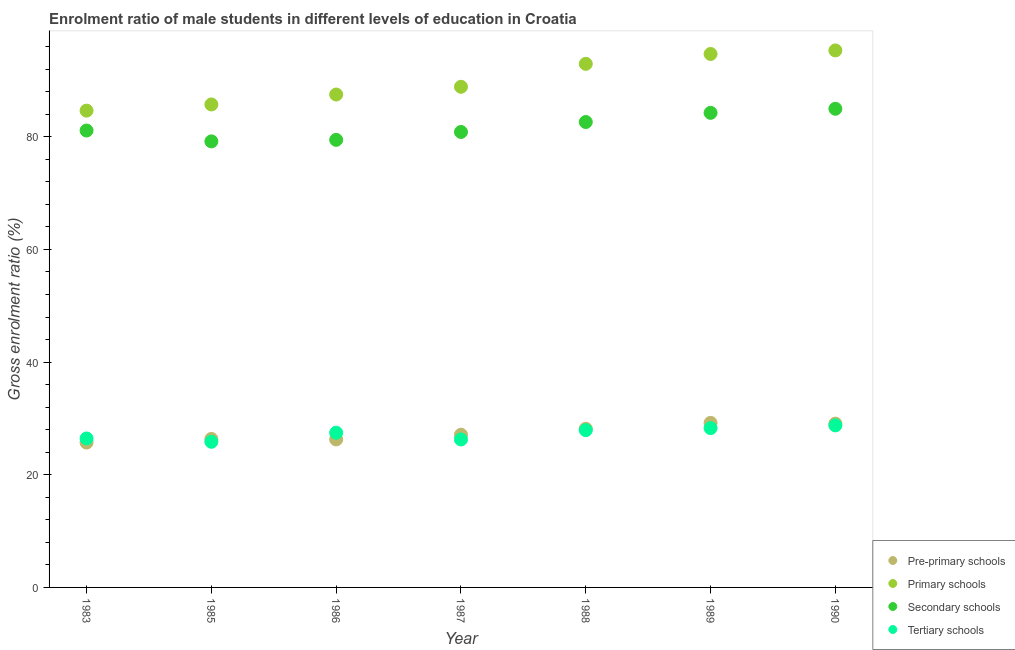How many different coloured dotlines are there?
Your response must be concise. 4. What is the gross enrolment ratio(female) in secondary schools in 1989?
Give a very brief answer. 84.25. Across all years, what is the maximum gross enrolment ratio(female) in tertiary schools?
Give a very brief answer. 28.77. Across all years, what is the minimum gross enrolment ratio(female) in primary schools?
Offer a terse response. 84.65. In which year was the gross enrolment ratio(female) in primary schools maximum?
Provide a succinct answer. 1990. What is the total gross enrolment ratio(female) in pre-primary schools in the graph?
Give a very brief answer. 191.93. What is the difference between the gross enrolment ratio(female) in tertiary schools in 1988 and that in 1990?
Offer a very short reply. -0.85. What is the difference between the gross enrolment ratio(female) in tertiary schools in 1983 and the gross enrolment ratio(female) in secondary schools in 1986?
Offer a very short reply. -53.02. What is the average gross enrolment ratio(female) in tertiary schools per year?
Ensure brevity in your answer.  27.29. In the year 1986, what is the difference between the gross enrolment ratio(female) in secondary schools and gross enrolment ratio(female) in primary schools?
Your answer should be compact. -8.05. In how many years, is the gross enrolment ratio(female) in pre-primary schools greater than 60 %?
Make the answer very short. 0. What is the ratio of the gross enrolment ratio(female) in secondary schools in 1987 to that in 1990?
Offer a very short reply. 0.95. Is the gross enrolment ratio(female) in secondary schools in 1985 less than that in 1989?
Your answer should be very brief. Yes. What is the difference between the highest and the second highest gross enrolment ratio(female) in tertiary schools?
Your answer should be very brief. 0.49. What is the difference between the highest and the lowest gross enrolment ratio(female) in pre-primary schools?
Your response must be concise. 3.49. In how many years, is the gross enrolment ratio(female) in primary schools greater than the average gross enrolment ratio(female) in primary schools taken over all years?
Your answer should be very brief. 3. Is the sum of the gross enrolment ratio(female) in secondary schools in 1983 and 1990 greater than the maximum gross enrolment ratio(female) in pre-primary schools across all years?
Offer a very short reply. Yes. Are the values on the major ticks of Y-axis written in scientific E-notation?
Offer a terse response. No. Where does the legend appear in the graph?
Your response must be concise. Bottom right. What is the title of the graph?
Make the answer very short. Enrolment ratio of male students in different levels of education in Croatia. What is the Gross enrolment ratio (%) of Pre-primary schools in 1983?
Your answer should be very brief. 25.72. What is the Gross enrolment ratio (%) of Primary schools in 1983?
Your answer should be compact. 84.65. What is the Gross enrolment ratio (%) of Secondary schools in 1983?
Make the answer very short. 81.12. What is the Gross enrolment ratio (%) in Tertiary schools in 1983?
Your answer should be very brief. 26.44. What is the Gross enrolment ratio (%) of Pre-primary schools in 1985?
Offer a very short reply. 26.36. What is the Gross enrolment ratio (%) in Primary schools in 1985?
Your answer should be very brief. 85.74. What is the Gross enrolment ratio (%) of Secondary schools in 1985?
Your response must be concise. 79.19. What is the Gross enrolment ratio (%) in Tertiary schools in 1985?
Offer a very short reply. 25.86. What is the Gross enrolment ratio (%) of Pre-primary schools in 1986?
Your response must be concise. 26.27. What is the Gross enrolment ratio (%) of Primary schools in 1986?
Provide a succinct answer. 87.51. What is the Gross enrolment ratio (%) in Secondary schools in 1986?
Offer a terse response. 79.46. What is the Gross enrolment ratio (%) in Tertiary schools in 1986?
Your answer should be very brief. 27.47. What is the Gross enrolment ratio (%) of Pre-primary schools in 1987?
Provide a short and direct response. 27.11. What is the Gross enrolment ratio (%) in Primary schools in 1987?
Your answer should be very brief. 88.88. What is the Gross enrolment ratio (%) in Secondary schools in 1987?
Your response must be concise. 80.86. What is the Gross enrolment ratio (%) in Tertiary schools in 1987?
Make the answer very short. 26.27. What is the Gross enrolment ratio (%) of Pre-primary schools in 1988?
Offer a very short reply. 28.17. What is the Gross enrolment ratio (%) of Primary schools in 1988?
Offer a terse response. 92.95. What is the Gross enrolment ratio (%) in Secondary schools in 1988?
Provide a succinct answer. 82.62. What is the Gross enrolment ratio (%) in Tertiary schools in 1988?
Give a very brief answer. 27.92. What is the Gross enrolment ratio (%) of Pre-primary schools in 1989?
Your answer should be compact. 29.21. What is the Gross enrolment ratio (%) of Primary schools in 1989?
Your answer should be compact. 94.71. What is the Gross enrolment ratio (%) in Secondary schools in 1989?
Offer a very short reply. 84.25. What is the Gross enrolment ratio (%) of Tertiary schools in 1989?
Keep it short and to the point. 28.28. What is the Gross enrolment ratio (%) of Pre-primary schools in 1990?
Your answer should be very brief. 29.08. What is the Gross enrolment ratio (%) of Primary schools in 1990?
Offer a terse response. 95.34. What is the Gross enrolment ratio (%) in Secondary schools in 1990?
Offer a very short reply. 84.98. What is the Gross enrolment ratio (%) in Tertiary schools in 1990?
Offer a very short reply. 28.77. Across all years, what is the maximum Gross enrolment ratio (%) of Pre-primary schools?
Keep it short and to the point. 29.21. Across all years, what is the maximum Gross enrolment ratio (%) in Primary schools?
Provide a succinct answer. 95.34. Across all years, what is the maximum Gross enrolment ratio (%) in Secondary schools?
Your response must be concise. 84.98. Across all years, what is the maximum Gross enrolment ratio (%) of Tertiary schools?
Your response must be concise. 28.77. Across all years, what is the minimum Gross enrolment ratio (%) in Pre-primary schools?
Your response must be concise. 25.72. Across all years, what is the minimum Gross enrolment ratio (%) in Primary schools?
Your answer should be very brief. 84.65. Across all years, what is the minimum Gross enrolment ratio (%) of Secondary schools?
Provide a succinct answer. 79.19. Across all years, what is the minimum Gross enrolment ratio (%) in Tertiary schools?
Your response must be concise. 25.86. What is the total Gross enrolment ratio (%) in Pre-primary schools in the graph?
Provide a short and direct response. 191.93. What is the total Gross enrolment ratio (%) of Primary schools in the graph?
Provide a succinct answer. 629.77. What is the total Gross enrolment ratio (%) of Secondary schools in the graph?
Offer a terse response. 572.48. What is the total Gross enrolment ratio (%) of Tertiary schools in the graph?
Provide a succinct answer. 191.01. What is the difference between the Gross enrolment ratio (%) of Pre-primary schools in 1983 and that in 1985?
Provide a succinct answer. -0.65. What is the difference between the Gross enrolment ratio (%) of Primary schools in 1983 and that in 1985?
Your response must be concise. -1.1. What is the difference between the Gross enrolment ratio (%) of Secondary schools in 1983 and that in 1985?
Ensure brevity in your answer.  1.92. What is the difference between the Gross enrolment ratio (%) of Tertiary schools in 1983 and that in 1985?
Provide a succinct answer. 0.59. What is the difference between the Gross enrolment ratio (%) in Pre-primary schools in 1983 and that in 1986?
Offer a very short reply. -0.56. What is the difference between the Gross enrolment ratio (%) of Primary schools in 1983 and that in 1986?
Offer a very short reply. -2.86. What is the difference between the Gross enrolment ratio (%) in Secondary schools in 1983 and that in 1986?
Make the answer very short. 1.66. What is the difference between the Gross enrolment ratio (%) of Tertiary schools in 1983 and that in 1986?
Offer a very short reply. -1.02. What is the difference between the Gross enrolment ratio (%) of Pre-primary schools in 1983 and that in 1987?
Ensure brevity in your answer.  -1.39. What is the difference between the Gross enrolment ratio (%) in Primary schools in 1983 and that in 1987?
Offer a terse response. -4.23. What is the difference between the Gross enrolment ratio (%) in Secondary schools in 1983 and that in 1987?
Your answer should be very brief. 0.26. What is the difference between the Gross enrolment ratio (%) in Tertiary schools in 1983 and that in 1987?
Provide a short and direct response. 0.18. What is the difference between the Gross enrolment ratio (%) of Pre-primary schools in 1983 and that in 1988?
Your answer should be compact. -2.45. What is the difference between the Gross enrolment ratio (%) of Primary schools in 1983 and that in 1988?
Your answer should be very brief. -8.31. What is the difference between the Gross enrolment ratio (%) of Secondary schools in 1983 and that in 1988?
Make the answer very short. -1.51. What is the difference between the Gross enrolment ratio (%) of Tertiary schools in 1983 and that in 1988?
Offer a terse response. -1.48. What is the difference between the Gross enrolment ratio (%) of Pre-primary schools in 1983 and that in 1989?
Offer a terse response. -3.49. What is the difference between the Gross enrolment ratio (%) of Primary schools in 1983 and that in 1989?
Keep it short and to the point. -10.06. What is the difference between the Gross enrolment ratio (%) in Secondary schools in 1983 and that in 1989?
Make the answer very short. -3.14. What is the difference between the Gross enrolment ratio (%) in Tertiary schools in 1983 and that in 1989?
Keep it short and to the point. -1.84. What is the difference between the Gross enrolment ratio (%) of Pre-primary schools in 1983 and that in 1990?
Keep it short and to the point. -3.36. What is the difference between the Gross enrolment ratio (%) of Primary schools in 1983 and that in 1990?
Make the answer very short. -10.69. What is the difference between the Gross enrolment ratio (%) in Secondary schools in 1983 and that in 1990?
Provide a succinct answer. -3.86. What is the difference between the Gross enrolment ratio (%) in Tertiary schools in 1983 and that in 1990?
Give a very brief answer. -2.32. What is the difference between the Gross enrolment ratio (%) of Pre-primary schools in 1985 and that in 1986?
Keep it short and to the point. 0.09. What is the difference between the Gross enrolment ratio (%) in Primary schools in 1985 and that in 1986?
Your answer should be compact. -1.77. What is the difference between the Gross enrolment ratio (%) in Secondary schools in 1985 and that in 1986?
Make the answer very short. -0.27. What is the difference between the Gross enrolment ratio (%) of Tertiary schools in 1985 and that in 1986?
Give a very brief answer. -1.61. What is the difference between the Gross enrolment ratio (%) of Pre-primary schools in 1985 and that in 1987?
Make the answer very short. -0.75. What is the difference between the Gross enrolment ratio (%) of Primary schools in 1985 and that in 1987?
Offer a very short reply. -3.14. What is the difference between the Gross enrolment ratio (%) in Secondary schools in 1985 and that in 1987?
Ensure brevity in your answer.  -1.67. What is the difference between the Gross enrolment ratio (%) in Tertiary schools in 1985 and that in 1987?
Give a very brief answer. -0.41. What is the difference between the Gross enrolment ratio (%) in Pre-primary schools in 1985 and that in 1988?
Offer a very short reply. -1.81. What is the difference between the Gross enrolment ratio (%) in Primary schools in 1985 and that in 1988?
Provide a short and direct response. -7.21. What is the difference between the Gross enrolment ratio (%) in Secondary schools in 1985 and that in 1988?
Make the answer very short. -3.43. What is the difference between the Gross enrolment ratio (%) of Tertiary schools in 1985 and that in 1988?
Keep it short and to the point. -2.07. What is the difference between the Gross enrolment ratio (%) in Pre-primary schools in 1985 and that in 1989?
Make the answer very short. -2.85. What is the difference between the Gross enrolment ratio (%) of Primary schools in 1985 and that in 1989?
Give a very brief answer. -8.96. What is the difference between the Gross enrolment ratio (%) of Secondary schools in 1985 and that in 1989?
Provide a short and direct response. -5.06. What is the difference between the Gross enrolment ratio (%) in Tertiary schools in 1985 and that in 1989?
Your answer should be very brief. -2.42. What is the difference between the Gross enrolment ratio (%) in Pre-primary schools in 1985 and that in 1990?
Keep it short and to the point. -2.71. What is the difference between the Gross enrolment ratio (%) of Primary schools in 1985 and that in 1990?
Provide a short and direct response. -9.59. What is the difference between the Gross enrolment ratio (%) in Secondary schools in 1985 and that in 1990?
Your answer should be compact. -5.79. What is the difference between the Gross enrolment ratio (%) in Tertiary schools in 1985 and that in 1990?
Offer a very short reply. -2.91. What is the difference between the Gross enrolment ratio (%) in Pre-primary schools in 1986 and that in 1987?
Provide a short and direct response. -0.84. What is the difference between the Gross enrolment ratio (%) in Primary schools in 1986 and that in 1987?
Your response must be concise. -1.37. What is the difference between the Gross enrolment ratio (%) in Secondary schools in 1986 and that in 1987?
Offer a terse response. -1.4. What is the difference between the Gross enrolment ratio (%) in Tertiary schools in 1986 and that in 1987?
Offer a very short reply. 1.2. What is the difference between the Gross enrolment ratio (%) in Pre-primary schools in 1986 and that in 1988?
Your answer should be very brief. -1.9. What is the difference between the Gross enrolment ratio (%) in Primary schools in 1986 and that in 1988?
Offer a very short reply. -5.44. What is the difference between the Gross enrolment ratio (%) of Secondary schools in 1986 and that in 1988?
Offer a terse response. -3.17. What is the difference between the Gross enrolment ratio (%) in Tertiary schools in 1986 and that in 1988?
Ensure brevity in your answer.  -0.46. What is the difference between the Gross enrolment ratio (%) of Pre-primary schools in 1986 and that in 1989?
Your answer should be compact. -2.94. What is the difference between the Gross enrolment ratio (%) of Primary schools in 1986 and that in 1989?
Your response must be concise. -7.2. What is the difference between the Gross enrolment ratio (%) in Secondary schools in 1986 and that in 1989?
Your answer should be compact. -4.79. What is the difference between the Gross enrolment ratio (%) of Tertiary schools in 1986 and that in 1989?
Provide a short and direct response. -0.81. What is the difference between the Gross enrolment ratio (%) of Pre-primary schools in 1986 and that in 1990?
Make the answer very short. -2.8. What is the difference between the Gross enrolment ratio (%) of Primary schools in 1986 and that in 1990?
Make the answer very short. -7.83. What is the difference between the Gross enrolment ratio (%) in Secondary schools in 1986 and that in 1990?
Offer a very short reply. -5.52. What is the difference between the Gross enrolment ratio (%) in Tertiary schools in 1986 and that in 1990?
Keep it short and to the point. -1.3. What is the difference between the Gross enrolment ratio (%) of Pre-primary schools in 1987 and that in 1988?
Give a very brief answer. -1.06. What is the difference between the Gross enrolment ratio (%) of Primary schools in 1987 and that in 1988?
Offer a very short reply. -4.07. What is the difference between the Gross enrolment ratio (%) in Secondary schools in 1987 and that in 1988?
Offer a very short reply. -1.77. What is the difference between the Gross enrolment ratio (%) of Tertiary schools in 1987 and that in 1988?
Make the answer very short. -1.65. What is the difference between the Gross enrolment ratio (%) of Pre-primary schools in 1987 and that in 1989?
Provide a short and direct response. -2.1. What is the difference between the Gross enrolment ratio (%) in Primary schools in 1987 and that in 1989?
Provide a short and direct response. -5.83. What is the difference between the Gross enrolment ratio (%) of Secondary schools in 1987 and that in 1989?
Your answer should be very brief. -3.39. What is the difference between the Gross enrolment ratio (%) in Tertiary schools in 1987 and that in 1989?
Provide a succinct answer. -2.01. What is the difference between the Gross enrolment ratio (%) in Pre-primary schools in 1987 and that in 1990?
Make the answer very short. -1.97. What is the difference between the Gross enrolment ratio (%) in Primary schools in 1987 and that in 1990?
Offer a very short reply. -6.45. What is the difference between the Gross enrolment ratio (%) of Secondary schools in 1987 and that in 1990?
Offer a terse response. -4.12. What is the difference between the Gross enrolment ratio (%) of Tertiary schools in 1987 and that in 1990?
Offer a very short reply. -2.5. What is the difference between the Gross enrolment ratio (%) in Pre-primary schools in 1988 and that in 1989?
Make the answer very short. -1.04. What is the difference between the Gross enrolment ratio (%) in Primary schools in 1988 and that in 1989?
Ensure brevity in your answer.  -1.75. What is the difference between the Gross enrolment ratio (%) of Secondary schools in 1988 and that in 1989?
Your answer should be very brief. -1.63. What is the difference between the Gross enrolment ratio (%) in Tertiary schools in 1988 and that in 1989?
Keep it short and to the point. -0.36. What is the difference between the Gross enrolment ratio (%) in Pre-primary schools in 1988 and that in 1990?
Offer a terse response. -0.91. What is the difference between the Gross enrolment ratio (%) in Primary schools in 1988 and that in 1990?
Provide a succinct answer. -2.38. What is the difference between the Gross enrolment ratio (%) of Secondary schools in 1988 and that in 1990?
Your answer should be compact. -2.35. What is the difference between the Gross enrolment ratio (%) of Tertiary schools in 1988 and that in 1990?
Ensure brevity in your answer.  -0.85. What is the difference between the Gross enrolment ratio (%) in Pre-primary schools in 1989 and that in 1990?
Give a very brief answer. 0.14. What is the difference between the Gross enrolment ratio (%) of Primary schools in 1989 and that in 1990?
Provide a short and direct response. -0.63. What is the difference between the Gross enrolment ratio (%) of Secondary schools in 1989 and that in 1990?
Offer a terse response. -0.73. What is the difference between the Gross enrolment ratio (%) in Tertiary schools in 1989 and that in 1990?
Keep it short and to the point. -0.49. What is the difference between the Gross enrolment ratio (%) of Pre-primary schools in 1983 and the Gross enrolment ratio (%) of Primary schools in 1985?
Keep it short and to the point. -60.02. What is the difference between the Gross enrolment ratio (%) in Pre-primary schools in 1983 and the Gross enrolment ratio (%) in Secondary schools in 1985?
Offer a terse response. -53.47. What is the difference between the Gross enrolment ratio (%) in Pre-primary schools in 1983 and the Gross enrolment ratio (%) in Tertiary schools in 1985?
Offer a terse response. -0.14. What is the difference between the Gross enrolment ratio (%) of Primary schools in 1983 and the Gross enrolment ratio (%) of Secondary schools in 1985?
Give a very brief answer. 5.45. What is the difference between the Gross enrolment ratio (%) in Primary schools in 1983 and the Gross enrolment ratio (%) in Tertiary schools in 1985?
Offer a very short reply. 58.79. What is the difference between the Gross enrolment ratio (%) in Secondary schools in 1983 and the Gross enrolment ratio (%) in Tertiary schools in 1985?
Offer a very short reply. 55.26. What is the difference between the Gross enrolment ratio (%) in Pre-primary schools in 1983 and the Gross enrolment ratio (%) in Primary schools in 1986?
Offer a terse response. -61.79. What is the difference between the Gross enrolment ratio (%) in Pre-primary schools in 1983 and the Gross enrolment ratio (%) in Secondary schools in 1986?
Keep it short and to the point. -53.74. What is the difference between the Gross enrolment ratio (%) in Pre-primary schools in 1983 and the Gross enrolment ratio (%) in Tertiary schools in 1986?
Keep it short and to the point. -1.75. What is the difference between the Gross enrolment ratio (%) in Primary schools in 1983 and the Gross enrolment ratio (%) in Secondary schools in 1986?
Your answer should be very brief. 5.19. What is the difference between the Gross enrolment ratio (%) in Primary schools in 1983 and the Gross enrolment ratio (%) in Tertiary schools in 1986?
Ensure brevity in your answer.  57.18. What is the difference between the Gross enrolment ratio (%) of Secondary schools in 1983 and the Gross enrolment ratio (%) of Tertiary schools in 1986?
Keep it short and to the point. 53.65. What is the difference between the Gross enrolment ratio (%) in Pre-primary schools in 1983 and the Gross enrolment ratio (%) in Primary schools in 1987?
Your answer should be very brief. -63.16. What is the difference between the Gross enrolment ratio (%) of Pre-primary schools in 1983 and the Gross enrolment ratio (%) of Secondary schools in 1987?
Make the answer very short. -55.14. What is the difference between the Gross enrolment ratio (%) of Pre-primary schools in 1983 and the Gross enrolment ratio (%) of Tertiary schools in 1987?
Offer a terse response. -0.55. What is the difference between the Gross enrolment ratio (%) of Primary schools in 1983 and the Gross enrolment ratio (%) of Secondary schools in 1987?
Your answer should be compact. 3.79. What is the difference between the Gross enrolment ratio (%) of Primary schools in 1983 and the Gross enrolment ratio (%) of Tertiary schools in 1987?
Keep it short and to the point. 58.38. What is the difference between the Gross enrolment ratio (%) of Secondary schools in 1983 and the Gross enrolment ratio (%) of Tertiary schools in 1987?
Your answer should be very brief. 54.85. What is the difference between the Gross enrolment ratio (%) of Pre-primary schools in 1983 and the Gross enrolment ratio (%) of Primary schools in 1988?
Provide a short and direct response. -67.24. What is the difference between the Gross enrolment ratio (%) in Pre-primary schools in 1983 and the Gross enrolment ratio (%) in Secondary schools in 1988?
Keep it short and to the point. -56.91. What is the difference between the Gross enrolment ratio (%) of Pre-primary schools in 1983 and the Gross enrolment ratio (%) of Tertiary schools in 1988?
Make the answer very short. -2.2. What is the difference between the Gross enrolment ratio (%) in Primary schools in 1983 and the Gross enrolment ratio (%) in Secondary schools in 1988?
Provide a succinct answer. 2.02. What is the difference between the Gross enrolment ratio (%) of Primary schools in 1983 and the Gross enrolment ratio (%) of Tertiary schools in 1988?
Your answer should be compact. 56.72. What is the difference between the Gross enrolment ratio (%) of Secondary schools in 1983 and the Gross enrolment ratio (%) of Tertiary schools in 1988?
Provide a succinct answer. 53.19. What is the difference between the Gross enrolment ratio (%) in Pre-primary schools in 1983 and the Gross enrolment ratio (%) in Primary schools in 1989?
Provide a short and direct response. -68.99. What is the difference between the Gross enrolment ratio (%) of Pre-primary schools in 1983 and the Gross enrolment ratio (%) of Secondary schools in 1989?
Your answer should be very brief. -58.53. What is the difference between the Gross enrolment ratio (%) in Pre-primary schools in 1983 and the Gross enrolment ratio (%) in Tertiary schools in 1989?
Provide a succinct answer. -2.56. What is the difference between the Gross enrolment ratio (%) in Primary schools in 1983 and the Gross enrolment ratio (%) in Secondary schools in 1989?
Offer a very short reply. 0.39. What is the difference between the Gross enrolment ratio (%) of Primary schools in 1983 and the Gross enrolment ratio (%) of Tertiary schools in 1989?
Keep it short and to the point. 56.37. What is the difference between the Gross enrolment ratio (%) in Secondary schools in 1983 and the Gross enrolment ratio (%) in Tertiary schools in 1989?
Offer a very short reply. 52.84. What is the difference between the Gross enrolment ratio (%) in Pre-primary schools in 1983 and the Gross enrolment ratio (%) in Primary schools in 1990?
Offer a terse response. -69.62. What is the difference between the Gross enrolment ratio (%) of Pre-primary schools in 1983 and the Gross enrolment ratio (%) of Secondary schools in 1990?
Your response must be concise. -59.26. What is the difference between the Gross enrolment ratio (%) of Pre-primary schools in 1983 and the Gross enrolment ratio (%) of Tertiary schools in 1990?
Your answer should be compact. -3.05. What is the difference between the Gross enrolment ratio (%) in Primary schools in 1983 and the Gross enrolment ratio (%) in Secondary schools in 1990?
Offer a very short reply. -0.33. What is the difference between the Gross enrolment ratio (%) of Primary schools in 1983 and the Gross enrolment ratio (%) of Tertiary schools in 1990?
Provide a succinct answer. 55.88. What is the difference between the Gross enrolment ratio (%) of Secondary schools in 1983 and the Gross enrolment ratio (%) of Tertiary schools in 1990?
Make the answer very short. 52.35. What is the difference between the Gross enrolment ratio (%) in Pre-primary schools in 1985 and the Gross enrolment ratio (%) in Primary schools in 1986?
Provide a short and direct response. -61.15. What is the difference between the Gross enrolment ratio (%) of Pre-primary schools in 1985 and the Gross enrolment ratio (%) of Secondary schools in 1986?
Give a very brief answer. -53.1. What is the difference between the Gross enrolment ratio (%) in Pre-primary schools in 1985 and the Gross enrolment ratio (%) in Tertiary schools in 1986?
Provide a succinct answer. -1.1. What is the difference between the Gross enrolment ratio (%) in Primary schools in 1985 and the Gross enrolment ratio (%) in Secondary schools in 1986?
Ensure brevity in your answer.  6.28. What is the difference between the Gross enrolment ratio (%) in Primary schools in 1985 and the Gross enrolment ratio (%) in Tertiary schools in 1986?
Offer a very short reply. 58.27. What is the difference between the Gross enrolment ratio (%) of Secondary schools in 1985 and the Gross enrolment ratio (%) of Tertiary schools in 1986?
Your response must be concise. 51.72. What is the difference between the Gross enrolment ratio (%) in Pre-primary schools in 1985 and the Gross enrolment ratio (%) in Primary schools in 1987?
Provide a short and direct response. -62.52. What is the difference between the Gross enrolment ratio (%) of Pre-primary schools in 1985 and the Gross enrolment ratio (%) of Secondary schools in 1987?
Give a very brief answer. -54.5. What is the difference between the Gross enrolment ratio (%) in Pre-primary schools in 1985 and the Gross enrolment ratio (%) in Tertiary schools in 1987?
Your response must be concise. 0.1. What is the difference between the Gross enrolment ratio (%) of Primary schools in 1985 and the Gross enrolment ratio (%) of Secondary schools in 1987?
Your answer should be compact. 4.88. What is the difference between the Gross enrolment ratio (%) in Primary schools in 1985 and the Gross enrolment ratio (%) in Tertiary schools in 1987?
Provide a short and direct response. 59.47. What is the difference between the Gross enrolment ratio (%) of Secondary schools in 1985 and the Gross enrolment ratio (%) of Tertiary schools in 1987?
Provide a succinct answer. 52.92. What is the difference between the Gross enrolment ratio (%) in Pre-primary schools in 1985 and the Gross enrolment ratio (%) in Primary schools in 1988?
Your answer should be very brief. -66.59. What is the difference between the Gross enrolment ratio (%) of Pre-primary schools in 1985 and the Gross enrolment ratio (%) of Secondary schools in 1988?
Ensure brevity in your answer.  -56.26. What is the difference between the Gross enrolment ratio (%) in Pre-primary schools in 1985 and the Gross enrolment ratio (%) in Tertiary schools in 1988?
Provide a succinct answer. -1.56. What is the difference between the Gross enrolment ratio (%) in Primary schools in 1985 and the Gross enrolment ratio (%) in Secondary schools in 1988?
Make the answer very short. 3.12. What is the difference between the Gross enrolment ratio (%) of Primary schools in 1985 and the Gross enrolment ratio (%) of Tertiary schools in 1988?
Give a very brief answer. 57.82. What is the difference between the Gross enrolment ratio (%) in Secondary schools in 1985 and the Gross enrolment ratio (%) in Tertiary schools in 1988?
Your response must be concise. 51.27. What is the difference between the Gross enrolment ratio (%) of Pre-primary schools in 1985 and the Gross enrolment ratio (%) of Primary schools in 1989?
Your answer should be compact. -68.34. What is the difference between the Gross enrolment ratio (%) of Pre-primary schools in 1985 and the Gross enrolment ratio (%) of Secondary schools in 1989?
Make the answer very short. -57.89. What is the difference between the Gross enrolment ratio (%) of Pre-primary schools in 1985 and the Gross enrolment ratio (%) of Tertiary schools in 1989?
Offer a very short reply. -1.92. What is the difference between the Gross enrolment ratio (%) in Primary schools in 1985 and the Gross enrolment ratio (%) in Secondary schools in 1989?
Your response must be concise. 1.49. What is the difference between the Gross enrolment ratio (%) in Primary schools in 1985 and the Gross enrolment ratio (%) in Tertiary schools in 1989?
Make the answer very short. 57.46. What is the difference between the Gross enrolment ratio (%) in Secondary schools in 1985 and the Gross enrolment ratio (%) in Tertiary schools in 1989?
Keep it short and to the point. 50.91. What is the difference between the Gross enrolment ratio (%) in Pre-primary schools in 1985 and the Gross enrolment ratio (%) in Primary schools in 1990?
Offer a terse response. -68.97. What is the difference between the Gross enrolment ratio (%) of Pre-primary schools in 1985 and the Gross enrolment ratio (%) of Secondary schools in 1990?
Offer a very short reply. -58.61. What is the difference between the Gross enrolment ratio (%) of Pre-primary schools in 1985 and the Gross enrolment ratio (%) of Tertiary schools in 1990?
Provide a succinct answer. -2.4. What is the difference between the Gross enrolment ratio (%) in Primary schools in 1985 and the Gross enrolment ratio (%) in Secondary schools in 1990?
Make the answer very short. 0.76. What is the difference between the Gross enrolment ratio (%) in Primary schools in 1985 and the Gross enrolment ratio (%) in Tertiary schools in 1990?
Provide a succinct answer. 56.97. What is the difference between the Gross enrolment ratio (%) of Secondary schools in 1985 and the Gross enrolment ratio (%) of Tertiary schools in 1990?
Offer a terse response. 50.42. What is the difference between the Gross enrolment ratio (%) in Pre-primary schools in 1986 and the Gross enrolment ratio (%) in Primary schools in 1987?
Offer a terse response. -62.61. What is the difference between the Gross enrolment ratio (%) in Pre-primary schools in 1986 and the Gross enrolment ratio (%) in Secondary schools in 1987?
Offer a terse response. -54.59. What is the difference between the Gross enrolment ratio (%) of Pre-primary schools in 1986 and the Gross enrolment ratio (%) of Tertiary schools in 1987?
Your answer should be very brief. 0.01. What is the difference between the Gross enrolment ratio (%) of Primary schools in 1986 and the Gross enrolment ratio (%) of Secondary schools in 1987?
Provide a succinct answer. 6.65. What is the difference between the Gross enrolment ratio (%) of Primary schools in 1986 and the Gross enrolment ratio (%) of Tertiary schools in 1987?
Offer a terse response. 61.24. What is the difference between the Gross enrolment ratio (%) of Secondary schools in 1986 and the Gross enrolment ratio (%) of Tertiary schools in 1987?
Give a very brief answer. 53.19. What is the difference between the Gross enrolment ratio (%) of Pre-primary schools in 1986 and the Gross enrolment ratio (%) of Primary schools in 1988?
Provide a succinct answer. -66.68. What is the difference between the Gross enrolment ratio (%) in Pre-primary schools in 1986 and the Gross enrolment ratio (%) in Secondary schools in 1988?
Provide a short and direct response. -56.35. What is the difference between the Gross enrolment ratio (%) in Pre-primary schools in 1986 and the Gross enrolment ratio (%) in Tertiary schools in 1988?
Your answer should be very brief. -1.65. What is the difference between the Gross enrolment ratio (%) of Primary schools in 1986 and the Gross enrolment ratio (%) of Secondary schools in 1988?
Provide a succinct answer. 4.88. What is the difference between the Gross enrolment ratio (%) in Primary schools in 1986 and the Gross enrolment ratio (%) in Tertiary schools in 1988?
Provide a short and direct response. 59.59. What is the difference between the Gross enrolment ratio (%) of Secondary schools in 1986 and the Gross enrolment ratio (%) of Tertiary schools in 1988?
Your answer should be very brief. 51.54. What is the difference between the Gross enrolment ratio (%) of Pre-primary schools in 1986 and the Gross enrolment ratio (%) of Primary schools in 1989?
Provide a succinct answer. -68.43. What is the difference between the Gross enrolment ratio (%) in Pre-primary schools in 1986 and the Gross enrolment ratio (%) in Secondary schools in 1989?
Give a very brief answer. -57.98. What is the difference between the Gross enrolment ratio (%) of Pre-primary schools in 1986 and the Gross enrolment ratio (%) of Tertiary schools in 1989?
Offer a very short reply. -2.01. What is the difference between the Gross enrolment ratio (%) in Primary schools in 1986 and the Gross enrolment ratio (%) in Secondary schools in 1989?
Offer a terse response. 3.26. What is the difference between the Gross enrolment ratio (%) of Primary schools in 1986 and the Gross enrolment ratio (%) of Tertiary schools in 1989?
Give a very brief answer. 59.23. What is the difference between the Gross enrolment ratio (%) in Secondary schools in 1986 and the Gross enrolment ratio (%) in Tertiary schools in 1989?
Offer a very short reply. 51.18. What is the difference between the Gross enrolment ratio (%) of Pre-primary schools in 1986 and the Gross enrolment ratio (%) of Primary schools in 1990?
Provide a short and direct response. -69.06. What is the difference between the Gross enrolment ratio (%) of Pre-primary schools in 1986 and the Gross enrolment ratio (%) of Secondary schools in 1990?
Your answer should be compact. -58.7. What is the difference between the Gross enrolment ratio (%) of Pre-primary schools in 1986 and the Gross enrolment ratio (%) of Tertiary schools in 1990?
Offer a terse response. -2.49. What is the difference between the Gross enrolment ratio (%) of Primary schools in 1986 and the Gross enrolment ratio (%) of Secondary schools in 1990?
Your answer should be compact. 2.53. What is the difference between the Gross enrolment ratio (%) in Primary schools in 1986 and the Gross enrolment ratio (%) in Tertiary schools in 1990?
Ensure brevity in your answer.  58.74. What is the difference between the Gross enrolment ratio (%) of Secondary schools in 1986 and the Gross enrolment ratio (%) of Tertiary schools in 1990?
Give a very brief answer. 50.69. What is the difference between the Gross enrolment ratio (%) in Pre-primary schools in 1987 and the Gross enrolment ratio (%) in Primary schools in 1988?
Provide a succinct answer. -65.84. What is the difference between the Gross enrolment ratio (%) of Pre-primary schools in 1987 and the Gross enrolment ratio (%) of Secondary schools in 1988?
Keep it short and to the point. -55.51. What is the difference between the Gross enrolment ratio (%) in Pre-primary schools in 1987 and the Gross enrolment ratio (%) in Tertiary schools in 1988?
Your answer should be compact. -0.81. What is the difference between the Gross enrolment ratio (%) of Primary schools in 1987 and the Gross enrolment ratio (%) of Secondary schools in 1988?
Offer a very short reply. 6.26. What is the difference between the Gross enrolment ratio (%) of Primary schools in 1987 and the Gross enrolment ratio (%) of Tertiary schools in 1988?
Your response must be concise. 60.96. What is the difference between the Gross enrolment ratio (%) of Secondary schools in 1987 and the Gross enrolment ratio (%) of Tertiary schools in 1988?
Offer a terse response. 52.94. What is the difference between the Gross enrolment ratio (%) of Pre-primary schools in 1987 and the Gross enrolment ratio (%) of Primary schools in 1989?
Your answer should be compact. -67.6. What is the difference between the Gross enrolment ratio (%) of Pre-primary schools in 1987 and the Gross enrolment ratio (%) of Secondary schools in 1989?
Offer a terse response. -57.14. What is the difference between the Gross enrolment ratio (%) of Pre-primary schools in 1987 and the Gross enrolment ratio (%) of Tertiary schools in 1989?
Your response must be concise. -1.17. What is the difference between the Gross enrolment ratio (%) in Primary schools in 1987 and the Gross enrolment ratio (%) in Secondary schools in 1989?
Offer a very short reply. 4.63. What is the difference between the Gross enrolment ratio (%) of Primary schools in 1987 and the Gross enrolment ratio (%) of Tertiary schools in 1989?
Give a very brief answer. 60.6. What is the difference between the Gross enrolment ratio (%) in Secondary schools in 1987 and the Gross enrolment ratio (%) in Tertiary schools in 1989?
Your answer should be compact. 52.58. What is the difference between the Gross enrolment ratio (%) in Pre-primary schools in 1987 and the Gross enrolment ratio (%) in Primary schools in 1990?
Make the answer very short. -68.22. What is the difference between the Gross enrolment ratio (%) in Pre-primary schools in 1987 and the Gross enrolment ratio (%) in Secondary schools in 1990?
Your response must be concise. -57.87. What is the difference between the Gross enrolment ratio (%) of Pre-primary schools in 1987 and the Gross enrolment ratio (%) of Tertiary schools in 1990?
Offer a terse response. -1.66. What is the difference between the Gross enrolment ratio (%) of Primary schools in 1987 and the Gross enrolment ratio (%) of Secondary schools in 1990?
Make the answer very short. 3.9. What is the difference between the Gross enrolment ratio (%) in Primary schools in 1987 and the Gross enrolment ratio (%) in Tertiary schools in 1990?
Your response must be concise. 60.11. What is the difference between the Gross enrolment ratio (%) of Secondary schools in 1987 and the Gross enrolment ratio (%) of Tertiary schools in 1990?
Your answer should be compact. 52.09. What is the difference between the Gross enrolment ratio (%) of Pre-primary schools in 1988 and the Gross enrolment ratio (%) of Primary schools in 1989?
Your answer should be compact. -66.54. What is the difference between the Gross enrolment ratio (%) of Pre-primary schools in 1988 and the Gross enrolment ratio (%) of Secondary schools in 1989?
Provide a succinct answer. -56.08. What is the difference between the Gross enrolment ratio (%) in Pre-primary schools in 1988 and the Gross enrolment ratio (%) in Tertiary schools in 1989?
Offer a terse response. -0.11. What is the difference between the Gross enrolment ratio (%) in Primary schools in 1988 and the Gross enrolment ratio (%) in Secondary schools in 1989?
Ensure brevity in your answer.  8.7. What is the difference between the Gross enrolment ratio (%) in Primary schools in 1988 and the Gross enrolment ratio (%) in Tertiary schools in 1989?
Your answer should be very brief. 64.67. What is the difference between the Gross enrolment ratio (%) in Secondary schools in 1988 and the Gross enrolment ratio (%) in Tertiary schools in 1989?
Keep it short and to the point. 54.34. What is the difference between the Gross enrolment ratio (%) of Pre-primary schools in 1988 and the Gross enrolment ratio (%) of Primary schools in 1990?
Give a very brief answer. -67.17. What is the difference between the Gross enrolment ratio (%) of Pre-primary schools in 1988 and the Gross enrolment ratio (%) of Secondary schools in 1990?
Give a very brief answer. -56.81. What is the difference between the Gross enrolment ratio (%) in Pre-primary schools in 1988 and the Gross enrolment ratio (%) in Tertiary schools in 1990?
Your response must be concise. -0.6. What is the difference between the Gross enrolment ratio (%) in Primary schools in 1988 and the Gross enrolment ratio (%) in Secondary schools in 1990?
Provide a succinct answer. 7.98. What is the difference between the Gross enrolment ratio (%) in Primary schools in 1988 and the Gross enrolment ratio (%) in Tertiary schools in 1990?
Ensure brevity in your answer.  64.19. What is the difference between the Gross enrolment ratio (%) of Secondary schools in 1988 and the Gross enrolment ratio (%) of Tertiary schools in 1990?
Offer a very short reply. 53.86. What is the difference between the Gross enrolment ratio (%) in Pre-primary schools in 1989 and the Gross enrolment ratio (%) in Primary schools in 1990?
Offer a very short reply. -66.12. What is the difference between the Gross enrolment ratio (%) of Pre-primary schools in 1989 and the Gross enrolment ratio (%) of Secondary schools in 1990?
Your answer should be compact. -55.77. What is the difference between the Gross enrolment ratio (%) in Pre-primary schools in 1989 and the Gross enrolment ratio (%) in Tertiary schools in 1990?
Your answer should be compact. 0.44. What is the difference between the Gross enrolment ratio (%) in Primary schools in 1989 and the Gross enrolment ratio (%) in Secondary schools in 1990?
Your response must be concise. 9.73. What is the difference between the Gross enrolment ratio (%) in Primary schools in 1989 and the Gross enrolment ratio (%) in Tertiary schools in 1990?
Your response must be concise. 65.94. What is the difference between the Gross enrolment ratio (%) in Secondary schools in 1989 and the Gross enrolment ratio (%) in Tertiary schools in 1990?
Make the answer very short. 55.48. What is the average Gross enrolment ratio (%) in Pre-primary schools per year?
Provide a short and direct response. 27.42. What is the average Gross enrolment ratio (%) of Primary schools per year?
Keep it short and to the point. 89.97. What is the average Gross enrolment ratio (%) of Secondary schools per year?
Provide a succinct answer. 81.78. What is the average Gross enrolment ratio (%) of Tertiary schools per year?
Ensure brevity in your answer.  27.29. In the year 1983, what is the difference between the Gross enrolment ratio (%) in Pre-primary schools and Gross enrolment ratio (%) in Primary schools?
Provide a short and direct response. -58.93. In the year 1983, what is the difference between the Gross enrolment ratio (%) in Pre-primary schools and Gross enrolment ratio (%) in Secondary schools?
Provide a short and direct response. -55.4. In the year 1983, what is the difference between the Gross enrolment ratio (%) in Pre-primary schools and Gross enrolment ratio (%) in Tertiary schools?
Keep it short and to the point. -0.73. In the year 1983, what is the difference between the Gross enrolment ratio (%) in Primary schools and Gross enrolment ratio (%) in Secondary schools?
Your response must be concise. 3.53. In the year 1983, what is the difference between the Gross enrolment ratio (%) in Primary schools and Gross enrolment ratio (%) in Tertiary schools?
Offer a terse response. 58.2. In the year 1983, what is the difference between the Gross enrolment ratio (%) of Secondary schools and Gross enrolment ratio (%) of Tertiary schools?
Make the answer very short. 54.67. In the year 1985, what is the difference between the Gross enrolment ratio (%) in Pre-primary schools and Gross enrolment ratio (%) in Primary schools?
Your answer should be compact. -59.38. In the year 1985, what is the difference between the Gross enrolment ratio (%) in Pre-primary schools and Gross enrolment ratio (%) in Secondary schools?
Provide a short and direct response. -52.83. In the year 1985, what is the difference between the Gross enrolment ratio (%) in Pre-primary schools and Gross enrolment ratio (%) in Tertiary schools?
Ensure brevity in your answer.  0.51. In the year 1985, what is the difference between the Gross enrolment ratio (%) in Primary schools and Gross enrolment ratio (%) in Secondary schools?
Offer a very short reply. 6.55. In the year 1985, what is the difference between the Gross enrolment ratio (%) in Primary schools and Gross enrolment ratio (%) in Tertiary schools?
Offer a terse response. 59.89. In the year 1985, what is the difference between the Gross enrolment ratio (%) of Secondary schools and Gross enrolment ratio (%) of Tertiary schools?
Your response must be concise. 53.34. In the year 1986, what is the difference between the Gross enrolment ratio (%) in Pre-primary schools and Gross enrolment ratio (%) in Primary schools?
Ensure brevity in your answer.  -61.24. In the year 1986, what is the difference between the Gross enrolment ratio (%) in Pre-primary schools and Gross enrolment ratio (%) in Secondary schools?
Offer a terse response. -53.19. In the year 1986, what is the difference between the Gross enrolment ratio (%) of Pre-primary schools and Gross enrolment ratio (%) of Tertiary schools?
Ensure brevity in your answer.  -1.19. In the year 1986, what is the difference between the Gross enrolment ratio (%) in Primary schools and Gross enrolment ratio (%) in Secondary schools?
Keep it short and to the point. 8.05. In the year 1986, what is the difference between the Gross enrolment ratio (%) in Primary schools and Gross enrolment ratio (%) in Tertiary schools?
Keep it short and to the point. 60.04. In the year 1986, what is the difference between the Gross enrolment ratio (%) in Secondary schools and Gross enrolment ratio (%) in Tertiary schools?
Your answer should be very brief. 51.99. In the year 1987, what is the difference between the Gross enrolment ratio (%) in Pre-primary schools and Gross enrolment ratio (%) in Primary schools?
Offer a very short reply. -61.77. In the year 1987, what is the difference between the Gross enrolment ratio (%) in Pre-primary schools and Gross enrolment ratio (%) in Secondary schools?
Offer a very short reply. -53.75. In the year 1987, what is the difference between the Gross enrolment ratio (%) of Pre-primary schools and Gross enrolment ratio (%) of Tertiary schools?
Offer a very short reply. 0.84. In the year 1987, what is the difference between the Gross enrolment ratio (%) of Primary schools and Gross enrolment ratio (%) of Secondary schools?
Your response must be concise. 8.02. In the year 1987, what is the difference between the Gross enrolment ratio (%) of Primary schools and Gross enrolment ratio (%) of Tertiary schools?
Provide a short and direct response. 62.61. In the year 1987, what is the difference between the Gross enrolment ratio (%) in Secondary schools and Gross enrolment ratio (%) in Tertiary schools?
Offer a terse response. 54.59. In the year 1988, what is the difference between the Gross enrolment ratio (%) of Pre-primary schools and Gross enrolment ratio (%) of Primary schools?
Give a very brief answer. -64.78. In the year 1988, what is the difference between the Gross enrolment ratio (%) of Pre-primary schools and Gross enrolment ratio (%) of Secondary schools?
Keep it short and to the point. -54.46. In the year 1988, what is the difference between the Gross enrolment ratio (%) in Pre-primary schools and Gross enrolment ratio (%) in Tertiary schools?
Provide a succinct answer. 0.25. In the year 1988, what is the difference between the Gross enrolment ratio (%) of Primary schools and Gross enrolment ratio (%) of Secondary schools?
Provide a short and direct response. 10.33. In the year 1988, what is the difference between the Gross enrolment ratio (%) of Primary schools and Gross enrolment ratio (%) of Tertiary schools?
Make the answer very short. 65.03. In the year 1988, what is the difference between the Gross enrolment ratio (%) of Secondary schools and Gross enrolment ratio (%) of Tertiary schools?
Your answer should be compact. 54.7. In the year 1989, what is the difference between the Gross enrolment ratio (%) in Pre-primary schools and Gross enrolment ratio (%) in Primary schools?
Provide a short and direct response. -65.49. In the year 1989, what is the difference between the Gross enrolment ratio (%) of Pre-primary schools and Gross enrolment ratio (%) of Secondary schools?
Make the answer very short. -55.04. In the year 1989, what is the difference between the Gross enrolment ratio (%) of Pre-primary schools and Gross enrolment ratio (%) of Tertiary schools?
Ensure brevity in your answer.  0.93. In the year 1989, what is the difference between the Gross enrolment ratio (%) in Primary schools and Gross enrolment ratio (%) in Secondary schools?
Make the answer very short. 10.45. In the year 1989, what is the difference between the Gross enrolment ratio (%) in Primary schools and Gross enrolment ratio (%) in Tertiary schools?
Provide a succinct answer. 66.43. In the year 1989, what is the difference between the Gross enrolment ratio (%) in Secondary schools and Gross enrolment ratio (%) in Tertiary schools?
Make the answer very short. 55.97. In the year 1990, what is the difference between the Gross enrolment ratio (%) in Pre-primary schools and Gross enrolment ratio (%) in Primary schools?
Make the answer very short. -66.26. In the year 1990, what is the difference between the Gross enrolment ratio (%) of Pre-primary schools and Gross enrolment ratio (%) of Secondary schools?
Ensure brevity in your answer.  -55.9. In the year 1990, what is the difference between the Gross enrolment ratio (%) of Pre-primary schools and Gross enrolment ratio (%) of Tertiary schools?
Your answer should be compact. 0.31. In the year 1990, what is the difference between the Gross enrolment ratio (%) of Primary schools and Gross enrolment ratio (%) of Secondary schools?
Offer a very short reply. 10.36. In the year 1990, what is the difference between the Gross enrolment ratio (%) of Primary schools and Gross enrolment ratio (%) of Tertiary schools?
Provide a succinct answer. 66.57. In the year 1990, what is the difference between the Gross enrolment ratio (%) in Secondary schools and Gross enrolment ratio (%) in Tertiary schools?
Offer a very short reply. 56.21. What is the ratio of the Gross enrolment ratio (%) in Pre-primary schools in 1983 to that in 1985?
Your answer should be compact. 0.98. What is the ratio of the Gross enrolment ratio (%) in Primary schools in 1983 to that in 1985?
Your response must be concise. 0.99. What is the ratio of the Gross enrolment ratio (%) in Secondary schools in 1983 to that in 1985?
Make the answer very short. 1.02. What is the ratio of the Gross enrolment ratio (%) in Tertiary schools in 1983 to that in 1985?
Provide a succinct answer. 1.02. What is the ratio of the Gross enrolment ratio (%) in Pre-primary schools in 1983 to that in 1986?
Provide a succinct answer. 0.98. What is the ratio of the Gross enrolment ratio (%) of Primary schools in 1983 to that in 1986?
Your answer should be very brief. 0.97. What is the ratio of the Gross enrolment ratio (%) in Secondary schools in 1983 to that in 1986?
Ensure brevity in your answer.  1.02. What is the ratio of the Gross enrolment ratio (%) of Tertiary schools in 1983 to that in 1986?
Offer a very short reply. 0.96. What is the ratio of the Gross enrolment ratio (%) of Pre-primary schools in 1983 to that in 1987?
Make the answer very short. 0.95. What is the ratio of the Gross enrolment ratio (%) of Secondary schools in 1983 to that in 1987?
Ensure brevity in your answer.  1. What is the ratio of the Gross enrolment ratio (%) of Primary schools in 1983 to that in 1988?
Your response must be concise. 0.91. What is the ratio of the Gross enrolment ratio (%) of Secondary schools in 1983 to that in 1988?
Provide a succinct answer. 0.98. What is the ratio of the Gross enrolment ratio (%) of Tertiary schools in 1983 to that in 1988?
Your response must be concise. 0.95. What is the ratio of the Gross enrolment ratio (%) of Pre-primary schools in 1983 to that in 1989?
Ensure brevity in your answer.  0.88. What is the ratio of the Gross enrolment ratio (%) in Primary schools in 1983 to that in 1989?
Ensure brevity in your answer.  0.89. What is the ratio of the Gross enrolment ratio (%) in Secondary schools in 1983 to that in 1989?
Offer a very short reply. 0.96. What is the ratio of the Gross enrolment ratio (%) in Tertiary schools in 1983 to that in 1989?
Your answer should be compact. 0.94. What is the ratio of the Gross enrolment ratio (%) in Pre-primary schools in 1983 to that in 1990?
Provide a succinct answer. 0.88. What is the ratio of the Gross enrolment ratio (%) in Primary schools in 1983 to that in 1990?
Provide a short and direct response. 0.89. What is the ratio of the Gross enrolment ratio (%) of Secondary schools in 1983 to that in 1990?
Offer a terse response. 0.95. What is the ratio of the Gross enrolment ratio (%) in Tertiary schools in 1983 to that in 1990?
Offer a very short reply. 0.92. What is the ratio of the Gross enrolment ratio (%) in Pre-primary schools in 1985 to that in 1986?
Provide a short and direct response. 1. What is the ratio of the Gross enrolment ratio (%) of Primary schools in 1985 to that in 1986?
Your answer should be compact. 0.98. What is the ratio of the Gross enrolment ratio (%) of Tertiary schools in 1985 to that in 1986?
Keep it short and to the point. 0.94. What is the ratio of the Gross enrolment ratio (%) in Pre-primary schools in 1985 to that in 1987?
Your answer should be very brief. 0.97. What is the ratio of the Gross enrolment ratio (%) in Primary schools in 1985 to that in 1987?
Provide a succinct answer. 0.96. What is the ratio of the Gross enrolment ratio (%) in Secondary schools in 1985 to that in 1987?
Keep it short and to the point. 0.98. What is the ratio of the Gross enrolment ratio (%) in Tertiary schools in 1985 to that in 1987?
Make the answer very short. 0.98. What is the ratio of the Gross enrolment ratio (%) in Pre-primary schools in 1985 to that in 1988?
Keep it short and to the point. 0.94. What is the ratio of the Gross enrolment ratio (%) in Primary schools in 1985 to that in 1988?
Offer a very short reply. 0.92. What is the ratio of the Gross enrolment ratio (%) in Secondary schools in 1985 to that in 1988?
Offer a terse response. 0.96. What is the ratio of the Gross enrolment ratio (%) of Tertiary schools in 1985 to that in 1988?
Provide a short and direct response. 0.93. What is the ratio of the Gross enrolment ratio (%) in Pre-primary schools in 1985 to that in 1989?
Your answer should be very brief. 0.9. What is the ratio of the Gross enrolment ratio (%) in Primary schools in 1985 to that in 1989?
Provide a succinct answer. 0.91. What is the ratio of the Gross enrolment ratio (%) in Secondary schools in 1985 to that in 1989?
Offer a very short reply. 0.94. What is the ratio of the Gross enrolment ratio (%) in Tertiary schools in 1985 to that in 1989?
Your answer should be very brief. 0.91. What is the ratio of the Gross enrolment ratio (%) of Pre-primary schools in 1985 to that in 1990?
Make the answer very short. 0.91. What is the ratio of the Gross enrolment ratio (%) in Primary schools in 1985 to that in 1990?
Make the answer very short. 0.9. What is the ratio of the Gross enrolment ratio (%) of Secondary schools in 1985 to that in 1990?
Give a very brief answer. 0.93. What is the ratio of the Gross enrolment ratio (%) of Tertiary schools in 1985 to that in 1990?
Offer a terse response. 0.9. What is the ratio of the Gross enrolment ratio (%) in Pre-primary schools in 1986 to that in 1987?
Provide a short and direct response. 0.97. What is the ratio of the Gross enrolment ratio (%) of Primary schools in 1986 to that in 1987?
Offer a terse response. 0.98. What is the ratio of the Gross enrolment ratio (%) in Secondary schools in 1986 to that in 1987?
Your response must be concise. 0.98. What is the ratio of the Gross enrolment ratio (%) of Tertiary schools in 1986 to that in 1987?
Offer a terse response. 1.05. What is the ratio of the Gross enrolment ratio (%) of Pre-primary schools in 1986 to that in 1988?
Make the answer very short. 0.93. What is the ratio of the Gross enrolment ratio (%) of Primary schools in 1986 to that in 1988?
Your response must be concise. 0.94. What is the ratio of the Gross enrolment ratio (%) in Secondary schools in 1986 to that in 1988?
Your answer should be compact. 0.96. What is the ratio of the Gross enrolment ratio (%) of Tertiary schools in 1986 to that in 1988?
Make the answer very short. 0.98. What is the ratio of the Gross enrolment ratio (%) of Pre-primary schools in 1986 to that in 1989?
Give a very brief answer. 0.9. What is the ratio of the Gross enrolment ratio (%) of Primary schools in 1986 to that in 1989?
Offer a terse response. 0.92. What is the ratio of the Gross enrolment ratio (%) in Secondary schools in 1986 to that in 1989?
Keep it short and to the point. 0.94. What is the ratio of the Gross enrolment ratio (%) in Tertiary schools in 1986 to that in 1989?
Provide a short and direct response. 0.97. What is the ratio of the Gross enrolment ratio (%) in Pre-primary schools in 1986 to that in 1990?
Your answer should be compact. 0.9. What is the ratio of the Gross enrolment ratio (%) in Primary schools in 1986 to that in 1990?
Provide a short and direct response. 0.92. What is the ratio of the Gross enrolment ratio (%) in Secondary schools in 1986 to that in 1990?
Provide a short and direct response. 0.94. What is the ratio of the Gross enrolment ratio (%) of Tertiary schools in 1986 to that in 1990?
Offer a very short reply. 0.95. What is the ratio of the Gross enrolment ratio (%) in Pre-primary schools in 1987 to that in 1988?
Offer a very short reply. 0.96. What is the ratio of the Gross enrolment ratio (%) of Primary schools in 1987 to that in 1988?
Give a very brief answer. 0.96. What is the ratio of the Gross enrolment ratio (%) of Secondary schools in 1987 to that in 1988?
Your answer should be compact. 0.98. What is the ratio of the Gross enrolment ratio (%) in Tertiary schools in 1987 to that in 1988?
Provide a short and direct response. 0.94. What is the ratio of the Gross enrolment ratio (%) in Pre-primary schools in 1987 to that in 1989?
Offer a terse response. 0.93. What is the ratio of the Gross enrolment ratio (%) in Primary schools in 1987 to that in 1989?
Give a very brief answer. 0.94. What is the ratio of the Gross enrolment ratio (%) in Secondary schools in 1987 to that in 1989?
Your response must be concise. 0.96. What is the ratio of the Gross enrolment ratio (%) in Tertiary schools in 1987 to that in 1989?
Ensure brevity in your answer.  0.93. What is the ratio of the Gross enrolment ratio (%) of Pre-primary schools in 1987 to that in 1990?
Keep it short and to the point. 0.93. What is the ratio of the Gross enrolment ratio (%) of Primary schools in 1987 to that in 1990?
Give a very brief answer. 0.93. What is the ratio of the Gross enrolment ratio (%) of Secondary schools in 1987 to that in 1990?
Keep it short and to the point. 0.95. What is the ratio of the Gross enrolment ratio (%) of Tertiary schools in 1987 to that in 1990?
Ensure brevity in your answer.  0.91. What is the ratio of the Gross enrolment ratio (%) in Pre-primary schools in 1988 to that in 1989?
Your answer should be very brief. 0.96. What is the ratio of the Gross enrolment ratio (%) in Primary schools in 1988 to that in 1989?
Provide a short and direct response. 0.98. What is the ratio of the Gross enrolment ratio (%) of Secondary schools in 1988 to that in 1989?
Offer a terse response. 0.98. What is the ratio of the Gross enrolment ratio (%) of Tertiary schools in 1988 to that in 1989?
Keep it short and to the point. 0.99. What is the ratio of the Gross enrolment ratio (%) of Pre-primary schools in 1988 to that in 1990?
Offer a very short reply. 0.97. What is the ratio of the Gross enrolment ratio (%) of Secondary schools in 1988 to that in 1990?
Keep it short and to the point. 0.97. What is the ratio of the Gross enrolment ratio (%) in Tertiary schools in 1988 to that in 1990?
Your response must be concise. 0.97. What is the ratio of the Gross enrolment ratio (%) of Pre-primary schools in 1989 to that in 1990?
Give a very brief answer. 1. What is the ratio of the Gross enrolment ratio (%) of Secondary schools in 1989 to that in 1990?
Your answer should be very brief. 0.99. What is the difference between the highest and the second highest Gross enrolment ratio (%) in Pre-primary schools?
Keep it short and to the point. 0.14. What is the difference between the highest and the second highest Gross enrolment ratio (%) of Primary schools?
Offer a very short reply. 0.63. What is the difference between the highest and the second highest Gross enrolment ratio (%) of Secondary schools?
Ensure brevity in your answer.  0.73. What is the difference between the highest and the second highest Gross enrolment ratio (%) in Tertiary schools?
Ensure brevity in your answer.  0.49. What is the difference between the highest and the lowest Gross enrolment ratio (%) in Pre-primary schools?
Your answer should be compact. 3.49. What is the difference between the highest and the lowest Gross enrolment ratio (%) of Primary schools?
Provide a succinct answer. 10.69. What is the difference between the highest and the lowest Gross enrolment ratio (%) in Secondary schools?
Make the answer very short. 5.79. What is the difference between the highest and the lowest Gross enrolment ratio (%) in Tertiary schools?
Provide a succinct answer. 2.91. 